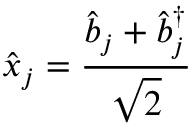Convert formula to latex. <formula><loc_0><loc_0><loc_500><loc_500>\hat { x } _ { j } = \frac { \hat { b } _ { j } + \hat { b } _ { j } ^ { \dagger } } { \sqrt { 2 } }</formula> 